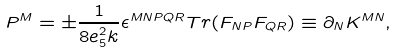<formula> <loc_0><loc_0><loc_500><loc_500>P ^ { M } = \pm \frac { 1 } { 8 e _ { 5 } ^ { 2 } k } \epsilon ^ { M N P Q R } T r ( F _ { N P } F _ { Q R } ) \equiv \partial _ { N } K ^ { M N } ,</formula> 